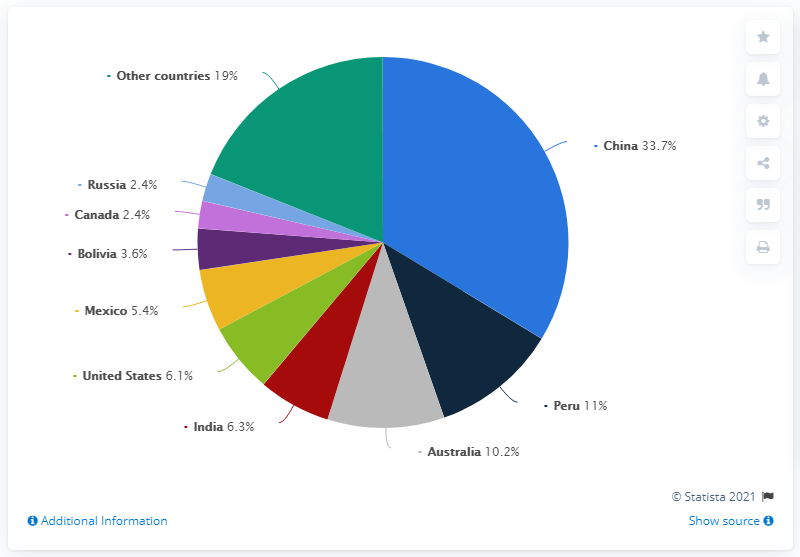Point out several critical features in this image. In 2019, China produced 33.7% of the world's total zinc production. In 2019, China was the world's largest producer of zinc from mines. Peru and Australia have a difference of approximately 0.8% in their country populations. The color of the country of India is red. 